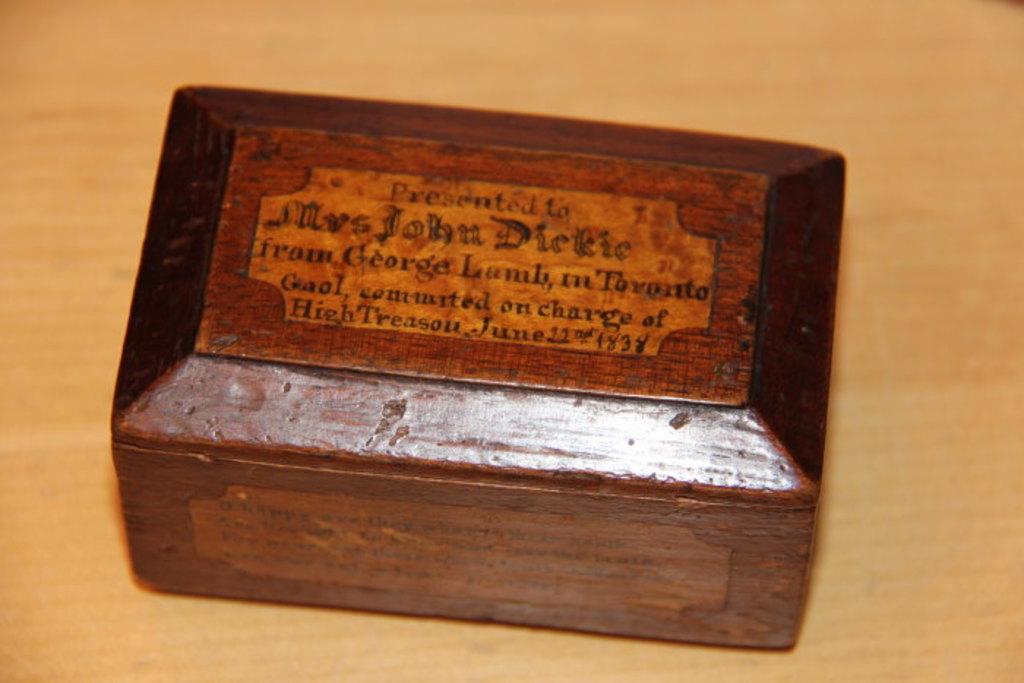What does the text say on the brown box?
Give a very brief answer. Unanswerable. 